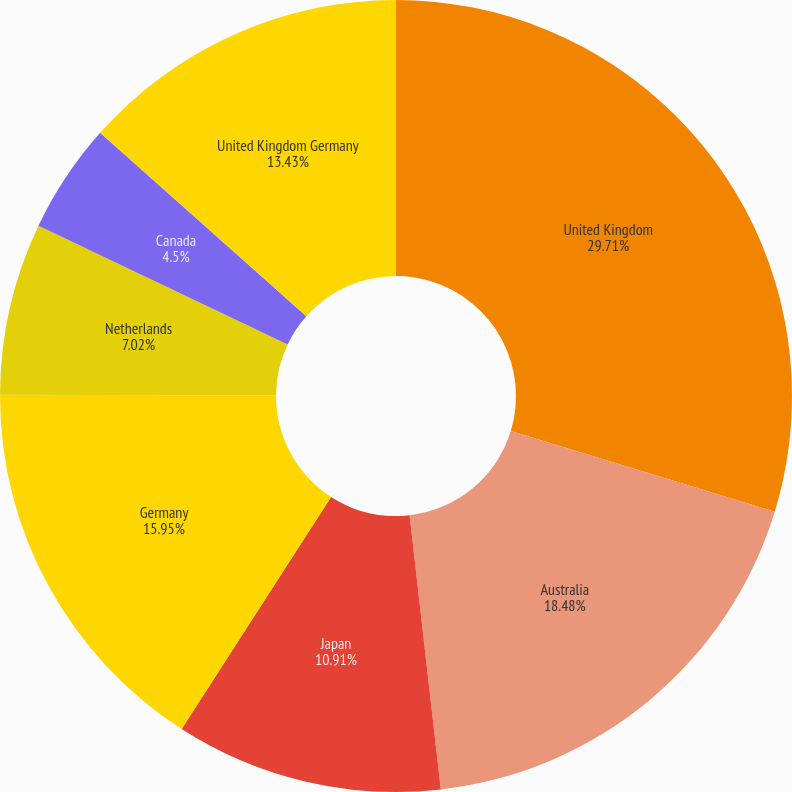Convert chart to OTSL. <chart><loc_0><loc_0><loc_500><loc_500><pie_chart><fcel>United Kingdom<fcel>Australia<fcel>Japan<fcel>Germany<fcel>Netherlands<fcel>Canada<fcel>United Kingdom Germany<nl><fcel>29.72%<fcel>18.48%<fcel>10.91%<fcel>15.95%<fcel>7.02%<fcel>4.5%<fcel>13.43%<nl></chart> 